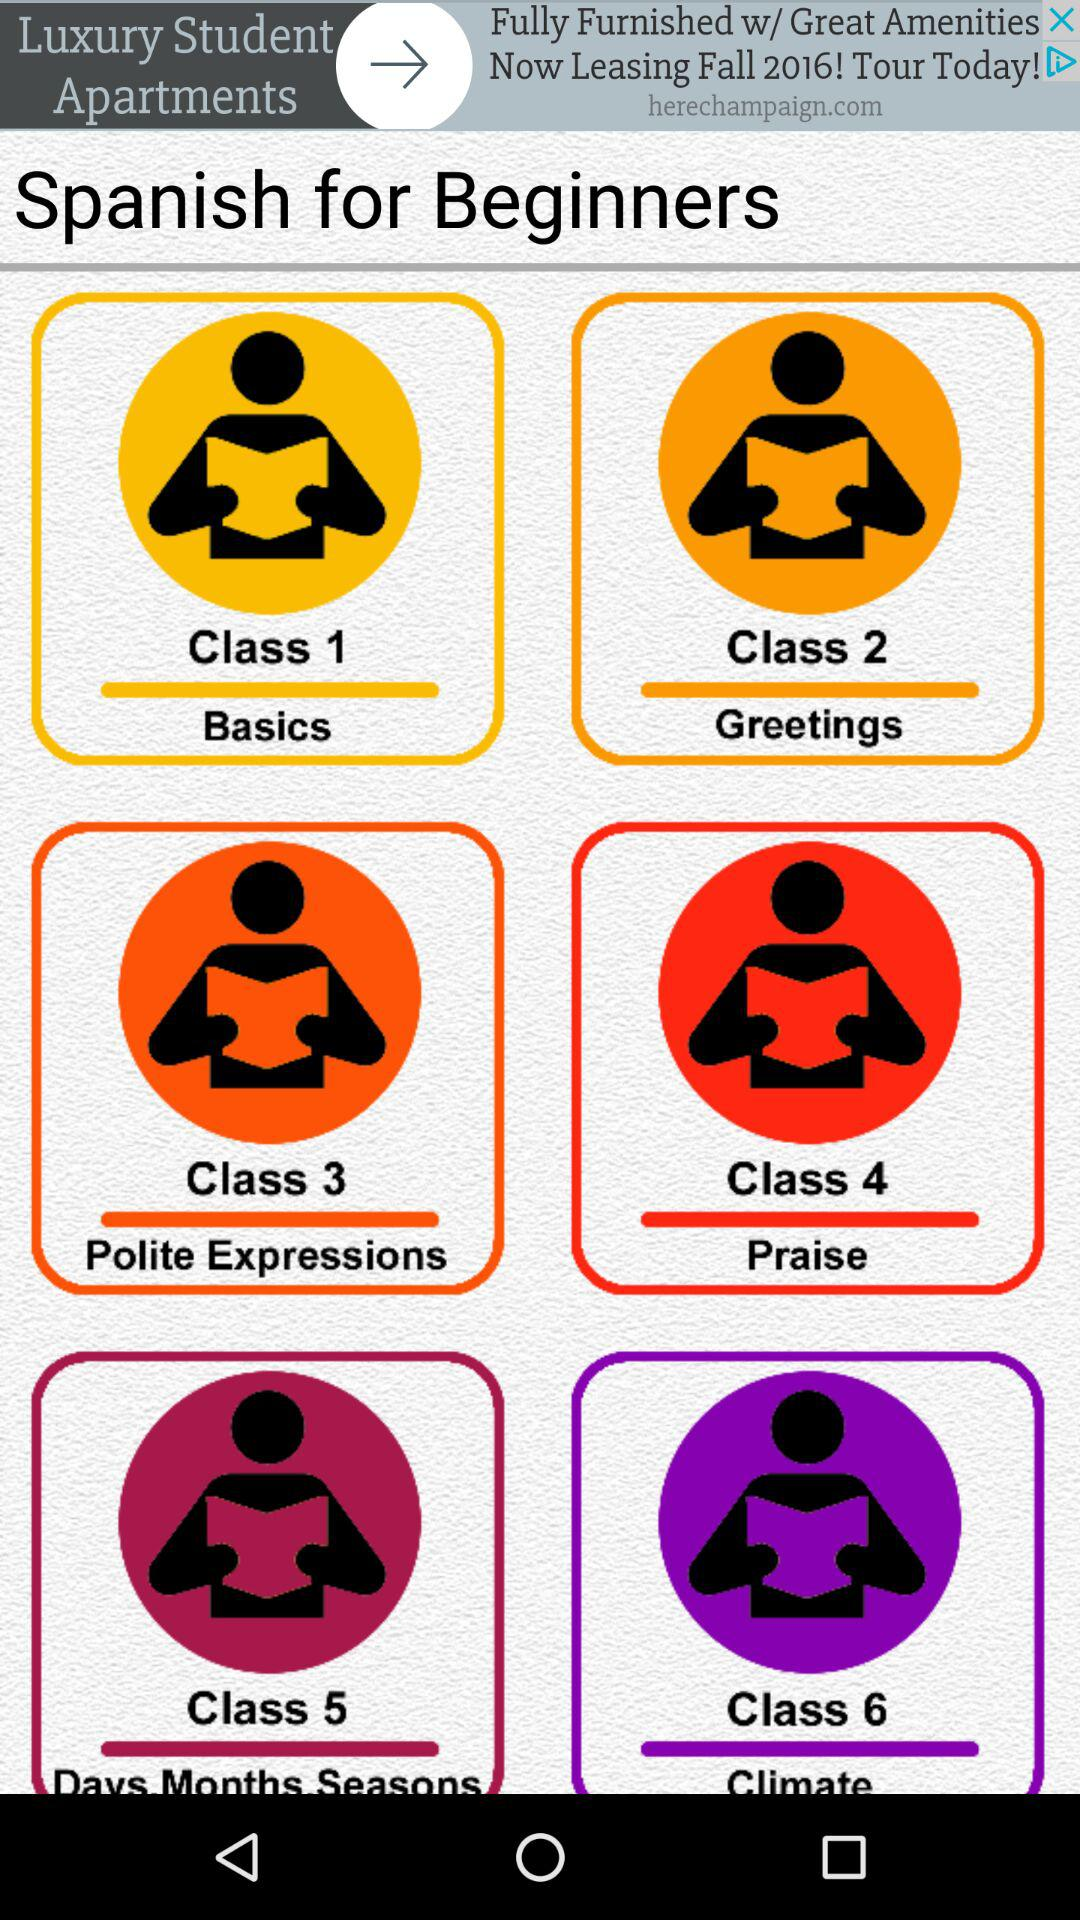How many classes are there in the Spanish for beginners course?
Answer the question using a single word or phrase. 6 